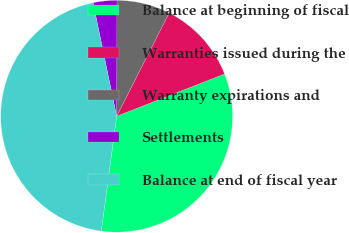Convert chart to OTSL. <chart><loc_0><loc_0><loc_500><loc_500><pie_chart><fcel>Balance at beginning of fiscal<fcel>Warranties issued during the<fcel>Warranty expirations and<fcel>Settlements<fcel>Balance at end of fiscal year<nl><fcel>33.06%<fcel>11.57%<fcel>7.44%<fcel>3.31%<fcel>44.63%<nl></chart> 